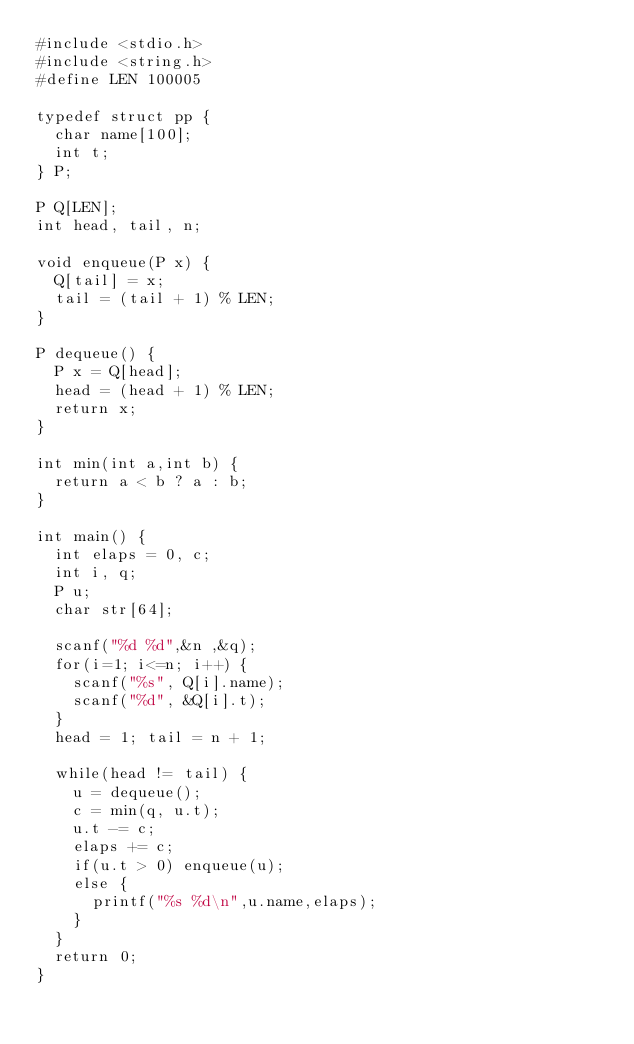Convert code to text. <code><loc_0><loc_0><loc_500><loc_500><_C_>#include <stdio.h>
#include <string.h>
#define LEN 100005
 
typedef struct pp {
  char name[100];
  int t;
} P;
 
P Q[LEN];
int head, tail, n;
 
void enqueue(P x) {
  Q[tail] = x;
  tail = (tail + 1) % LEN;
}
 
P dequeue() {
  P x = Q[head];
  head = (head + 1) % LEN;
  return x;
}
 
int min(int a,int b) {
  return a < b ? a : b; 
}
 
int main() {
  int elaps = 0, c;
  int i, q;
  P u;
  char str[64];
  
  scanf("%d %d",&n ,&q);
  for(i=1; i<=n; i++) {
    scanf("%s", Q[i].name);
    scanf("%d", &Q[i].t);
  }
  head = 1; tail = n + 1;
 
  while(head != tail) {
    u = dequeue();
    c = min(q, u.t);
    u.t -= c;
    elaps += c;
    if(u.t > 0) enqueue(u);
    else {
      printf("%s %d\n",u.name,elaps);
    }
  }
  return 0;
}
</code> 